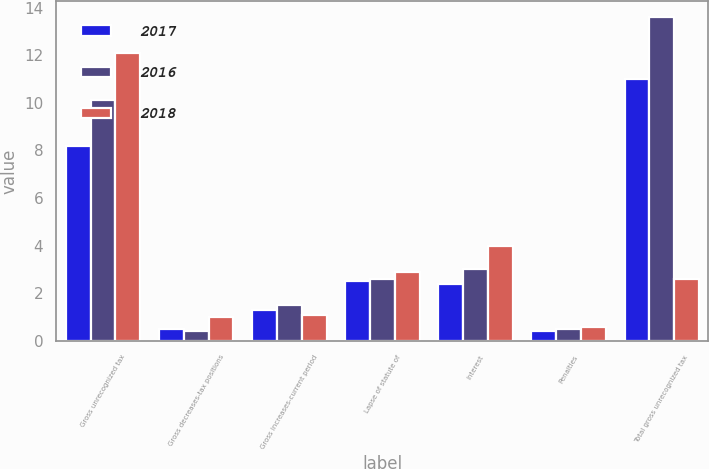<chart> <loc_0><loc_0><loc_500><loc_500><stacked_bar_chart><ecel><fcel>Gross unrecognized tax<fcel>Gross decreases-tax positions<fcel>Gross increases-current period<fcel>Lapse of statute of<fcel>Interest<fcel>Penalties<fcel>Total gross unrecognized tax<nl><fcel>2017<fcel>8.2<fcel>0.5<fcel>1.3<fcel>2.5<fcel>2.4<fcel>0.4<fcel>11<nl><fcel>2016<fcel>10.1<fcel>0.4<fcel>1.5<fcel>2.6<fcel>3<fcel>0.5<fcel>13.6<nl><fcel>2018<fcel>12.1<fcel>1<fcel>1.1<fcel>2.9<fcel>4<fcel>0.6<fcel>2.6<nl></chart> 